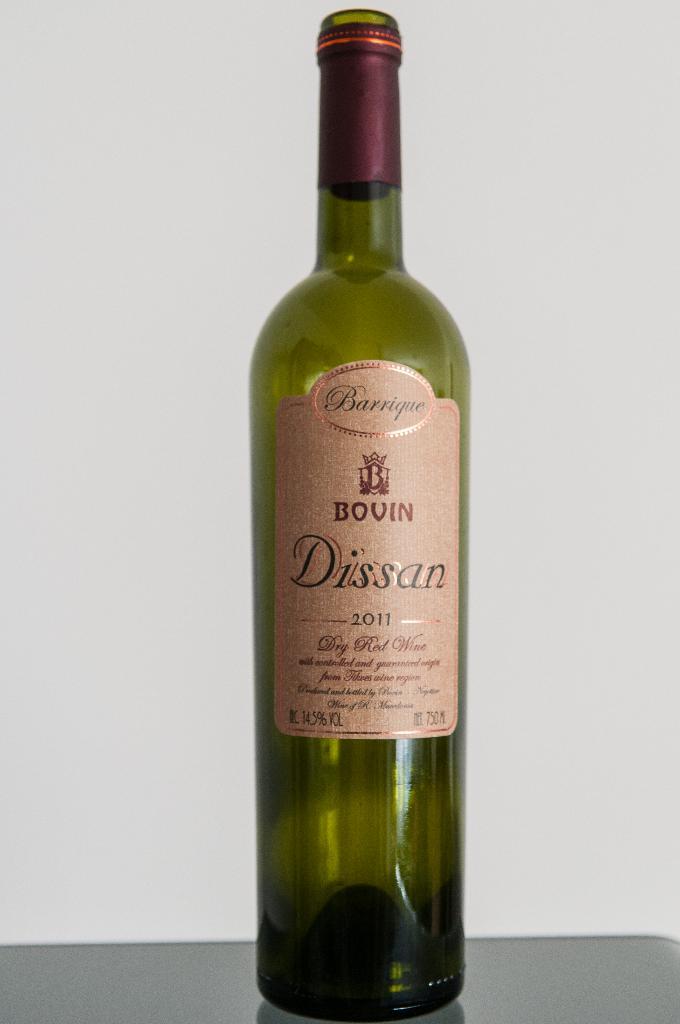What brand of alcohol is that?
Keep it short and to the point. Bovin. 